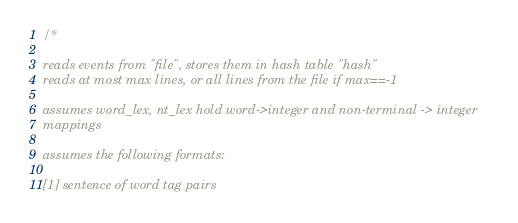Convert code to text. <code><loc_0><loc_0><loc_500><loc_500><_C_>
/* 

reads events from "file", stores them in hash table "hash"
reads at most max lines, or all lines from the file if max==-1

assumes word_lex, nt_lex hold word->integer and non-terminal -> integer 
mappings

assumes the following formats:

[1] sentence of word tag pairs   
</code> 